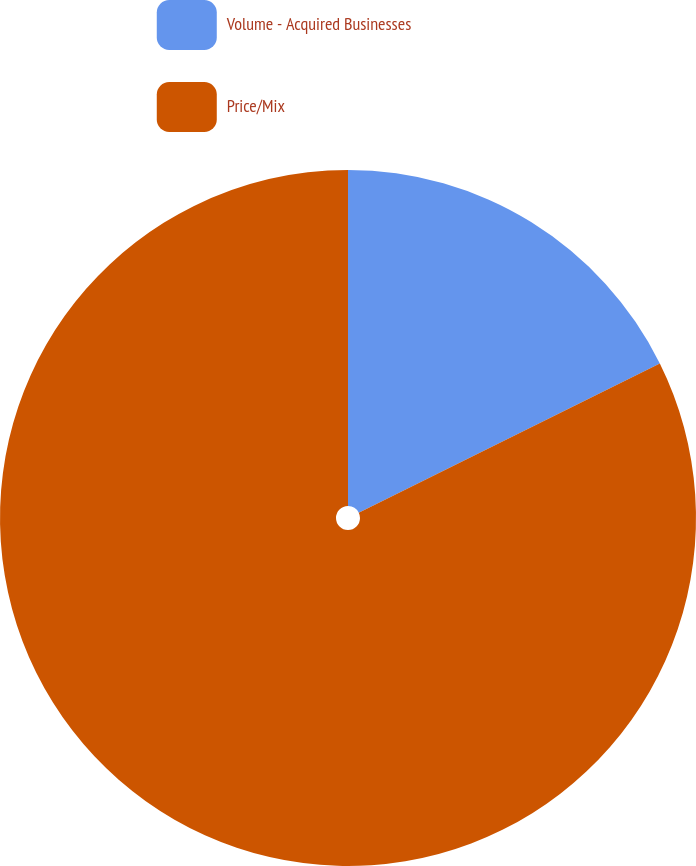<chart> <loc_0><loc_0><loc_500><loc_500><pie_chart><fcel>Volume - Acquired Businesses<fcel>Price/Mix<nl><fcel>17.68%<fcel>82.32%<nl></chart> 